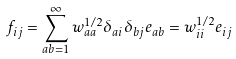<formula> <loc_0><loc_0><loc_500><loc_500>f _ { i j } = \sum _ { a b = 1 } ^ { \infty } w _ { a a } ^ { 1 / 2 } \delta _ { a i } \delta _ { b j } e _ { a b } = w _ { i i } ^ { 1 / 2 } e _ { i j }</formula> 